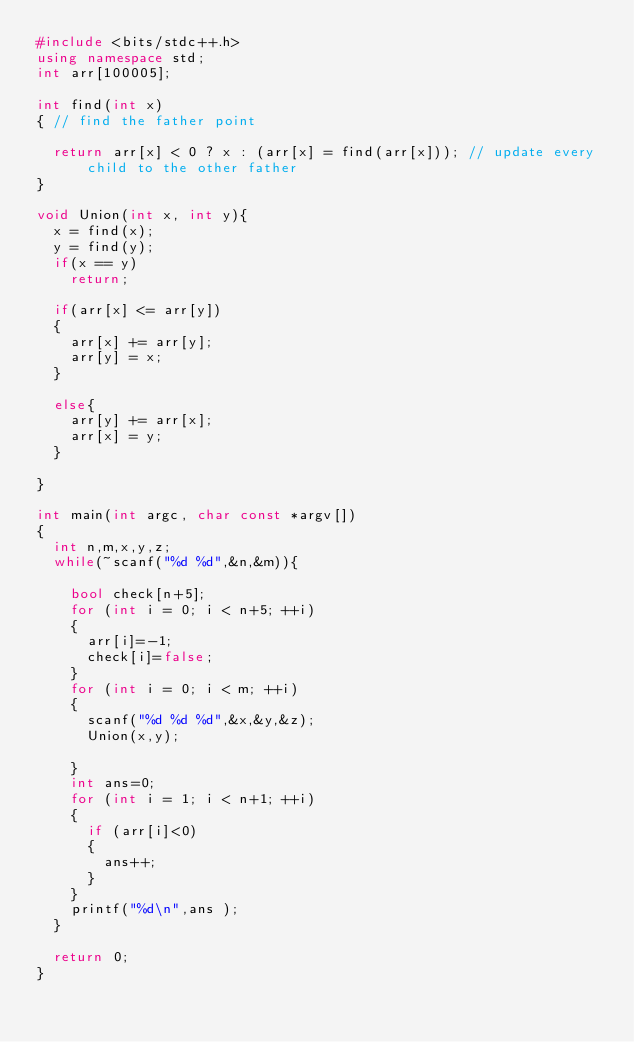Convert code to text. <code><loc_0><loc_0><loc_500><loc_500><_C++_>#include <bits/stdc++.h>
using namespace std;
int arr[100005];

int find(int x)
{ // find the father point

	return arr[x] < 0 ? x : (arr[x] = find(arr[x])); // update every child to the other father
}

void Union(int x, int y){
	x = find(x);
	y = find(y);
	if(x == y)
		return;

	if(arr[x] <= arr[y])
	{
		arr[x] += arr[y];
		arr[y] = x;
	}

	else{
		arr[y] += arr[x];
		arr[x] = y;
	}

}

int main(int argc, char const *argv[])
{
	int n,m,x,y,z;
	while(~scanf("%d %d",&n,&m)){
		
		bool check[n+5];
		for (int i = 0; i < n+5; ++i)
		{
			arr[i]=-1;
			check[i]=false;
		}
		for (int i = 0; i < m; ++i)
		{
			scanf("%d %d %d",&x,&y,&z);
			Union(x,y);
			
		}
		int ans=0;
		for (int i = 1; i < n+1; ++i)
		{
			if (arr[i]<0)
			{
				ans++;
			}
		}
		printf("%d\n",ans );
	}

	return 0;
}</code> 